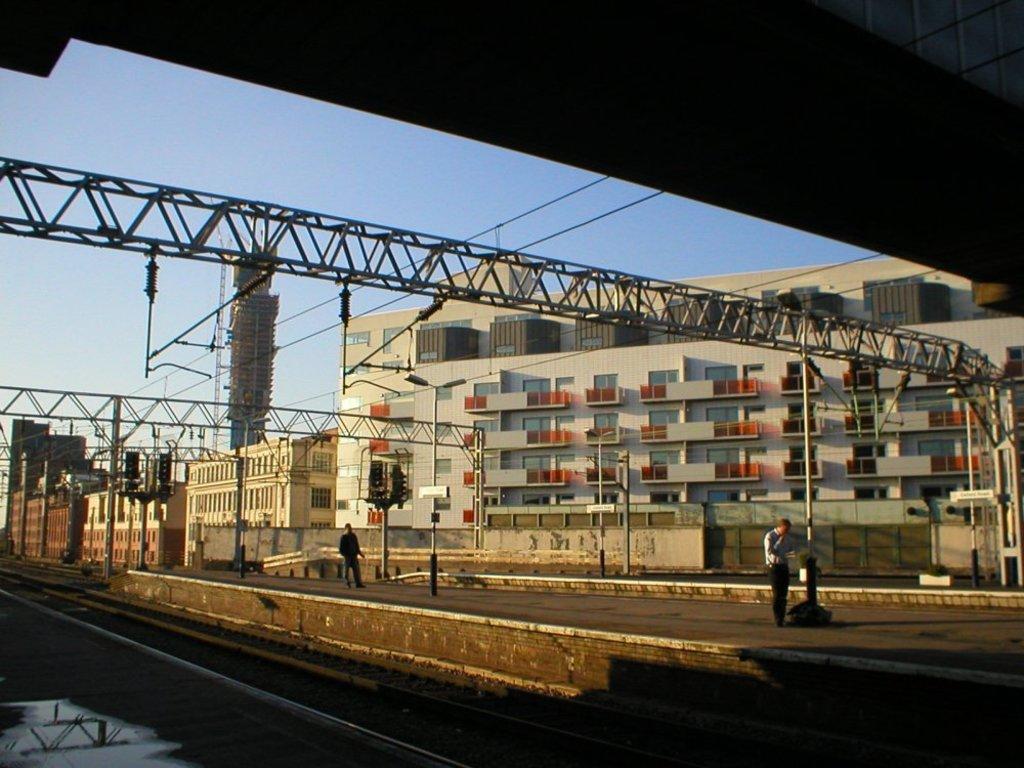In one or two sentences, can you explain what this image depicts? In this image we can see the railway tracks, people walking on the platform, wires, signal poles, wall, building and the sky in the background. 